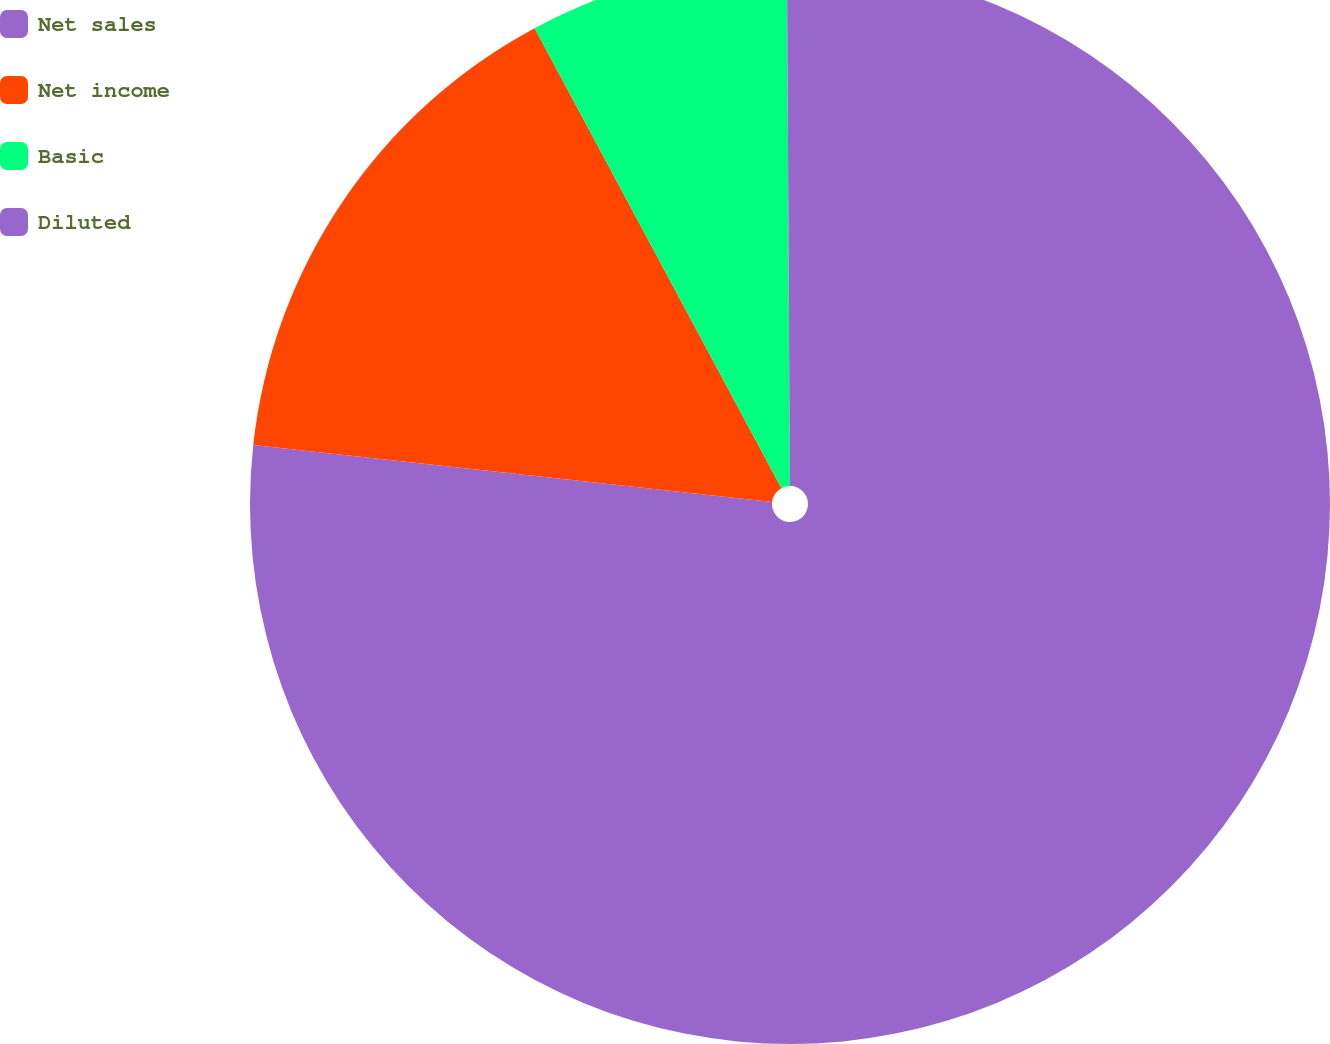Convert chart. <chart><loc_0><loc_0><loc_500><loc_500><pie_chart><fcel>Net sales<fcel>Net income<fcel>Basic<fcel>Diluted<nl><fcel>76.74%<fcel>15.42%<fcel>7.75%<fcel>0.09%<nl></chart> 